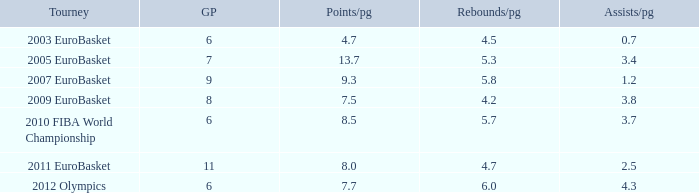How many assists per game have 4.2 rebounds per game? 3.8. 